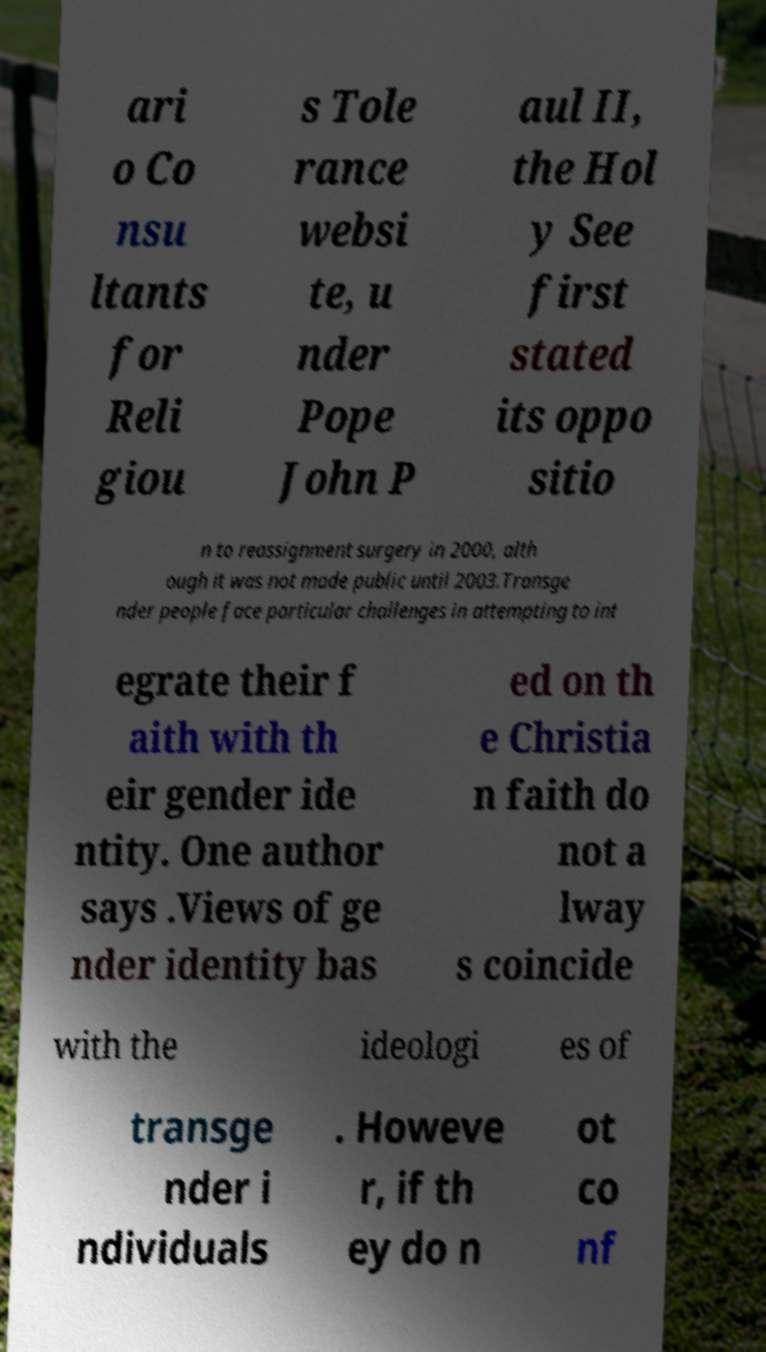Can you read and provide the text displayed in the image?This photo seems to have some interesting text. Can you extract and type it out for me? ari o Co nsu ltants for Reli giou s Tole rance websi te, u nder Pope John P aul II, the Hol y See first stated its oppo sitio n to reassignment surgery in 2000, alth ough it was not made public until 2003.Transge nder people face particular challenges in attempting to int egrate their f aith with th eir gender ide ntity. One author says .Views of ge nder identity bas ed on th e Christia n faith do not a lway s coincide with the ideologi es of transge nder i ndividuals . Howeve r, if th ey do n ot co nf 